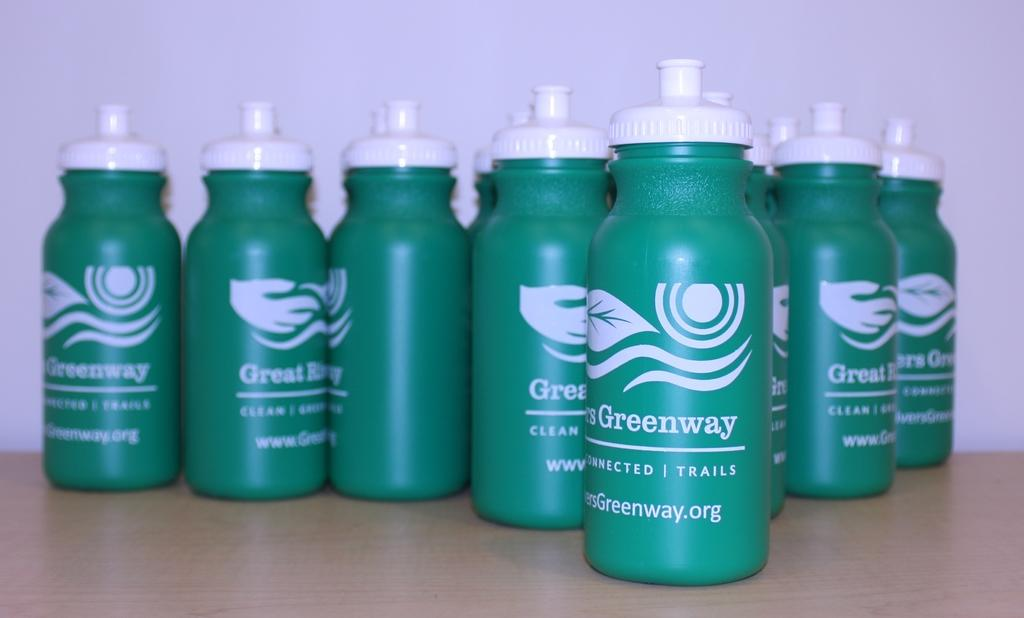<image>
Render a clear and concise summary of the photo. A number of green water bottles saying Greenway are lined up on a table. 